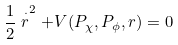<formula> <loc_0><loc_0><loc_500><loc_500>\frac { 1 } { 2 } \stackrel { \cdot } { r } ^ { 2 } + V ( P _ { \chi } , P _ { \phi } , r ) = 0</formula> 